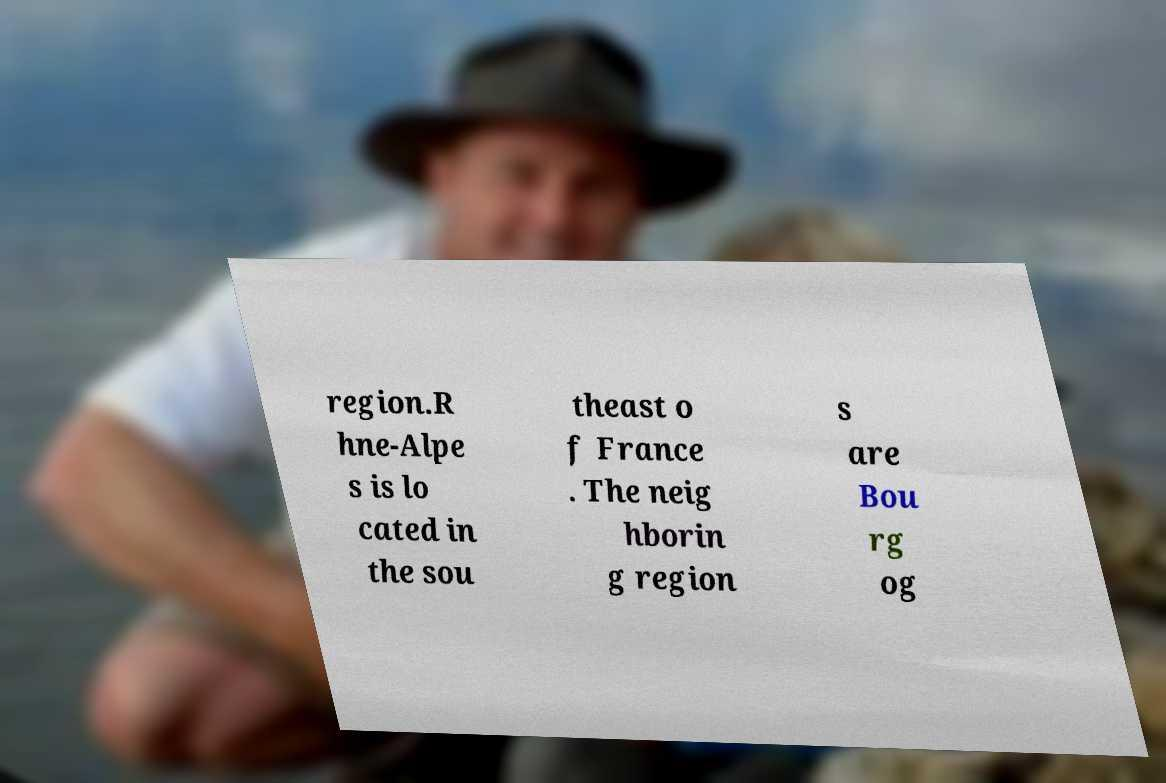Could you assist in decoding the text presented in this image and type it out clearly? region.R hne-Alpe s is lo cated in the sou theast o f France . The neig hborin g region s are Bou rg og 